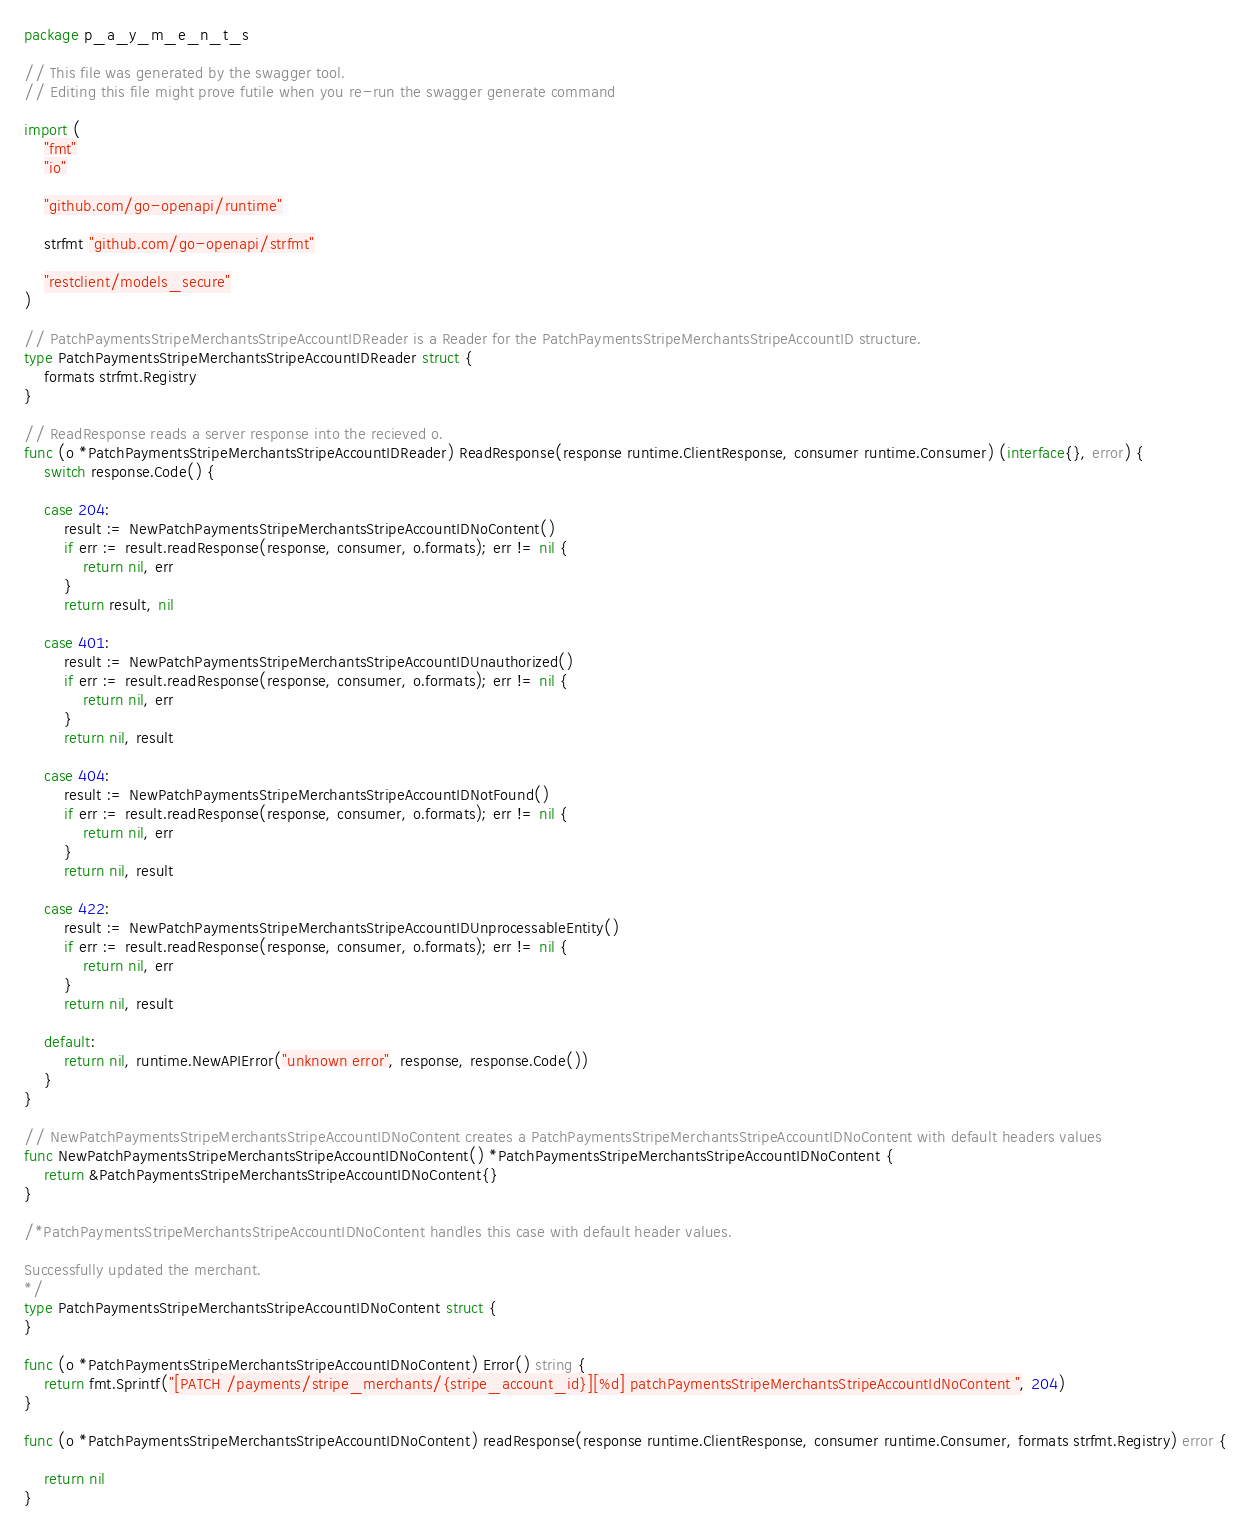Convert code to text. <code><loc_0><loc_0><loc_500><loc_500><_Go_>package p_a_y_m_e_n_t_s

// This file was generated by the swagger tool.
// Editing this file might prove futile when you re-run the swagger generate command

import (
	"fmt"
	"io"

	"github.com/go-openapi/runtime"

	strfmt "github.com/go-openapi/strfmt"

	"restclient/models_secure"
)

// PatchPaymentsStripeMerchantsStripeAccountIDReader is a Reader for the PatchPaymentsStripeMerchantsStripeAccountID structure.
type PatchPaymentsStripeMerchantsStripeAccountIDReader struct {
	formats strfmt.Registry
}

// ReadResponse reads a server response into the recieved o.
func (o *PatchPaymentsStripeMerchantsStripeAccountIDReader) ReadResponse(response runtime.ClientResponse, consumer runtime.Consumer) (interface{}, error) {
	switch response.Code() {

	case 204:
		result := NewPatchPaymentsStripeMerchantsStripeAccountIDNoContent()
		if err := result.readResponse(response, consumer, o.formats); err != nil {
			return nil, err
		}
		return result, nil

	case 401:
		result := NewPatchPaymentsStripeMerchantsStripeAccountIDUnauthorized()
		if err := result.readResponse(response, consumer, o.formats); err != nil {
			return nil, err
		}
		return nil, result

	case 404:
		result := NewPatchPaymentsStripeMerchantsStripeAccountIDNotFound()
		if err := result.readResponse(response, consumer, o.formats); err != nil {
			return nil, err
		}
		return nil, result

	case 422:
		result := NewPatchPaymentsStripeMerchantsStripeAccountIDUnprocessableEntity()
		if err := result.readResponse(response, consumer, o.formats); err != nil {
			return nil, err
		}
		return nil, result

	default:
		return nil, runtime.NewAPIError("unknown error", response, response.Code())
	}
}

// NewPatchPaymentsStripeMerchantsStripeAccountIDNoContent creates a PatchPaymentsStripeMerchantsStripeAccountIDNoContent with default headers values
func NewPatchPaymentsStripeMerchantsStripeAccountIDNoContent() *PatchPaymentsStripeMerchantsStripeAccountIDNoContent {
	return &PatchPaymentsStripeMerchantsStripeAccountIDNoContent{}
}

/*PatchPaymentsStripeMerchantsStripeAccountIDNoContent handles this case with default header values.

Successfully updated the merchant.
*/
type PatchPaymentsStripeMerchantsStripeAccountIDNoContent struct {
}

func (o *PatchPaymentsStripeMerchantsStripeAccountIDNoContent) Error() string {
	return fmt.Sprintf("[PATCH /payments/stripe_merchants/{stripe_account_id}][%d] patchPaymentsStripeMerchantsStripeAccountIdNoContent ", 204)
}

func (o *PatchPaymentsStripeMerchantsStripeAccountIDNoContent) readResponse(response runtime.ClientResponse, consumer runtime.Consumer, formats strfmt.Registry) error {

	return nil
}
</code> 